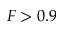<formula> <loc_0><loc_0><loc_500><loc_500>F > 0 . 9</formula> 